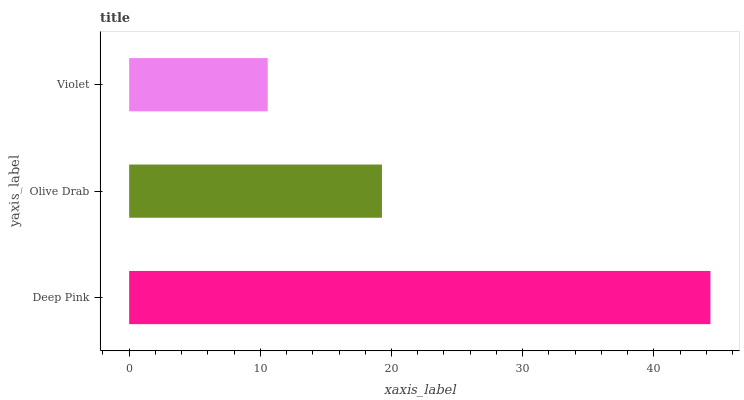Is Violet the minimum?
Answer yes or no. Yes. Is Deep Pink the maximum?
Answer yes or no. Yes. Is Olive Drab the minimum?
Answer yes or no. No. Is Olive Drab the maximum?
Answer yes or no. No. Is Deep Pink greater than Olive Drab?
Answer yes or no. Yes. Is Olive Drab less than Deep Pink?
Answer yes or no. Yes. Is Olive Drab greater than Deep Pink?
Answer yes or no. No. Is Deep Pink less than Olive Drab?
Answer yes or no. No. Is Olive Drab the high median?
Answer yes or no. Yes. Is Olive Drab the low median?
Answer yes or no. Yes. Is Deep Pink the high median?
Answer yes or no. No. Is Violet the low median?
Answer yes or no. No. 